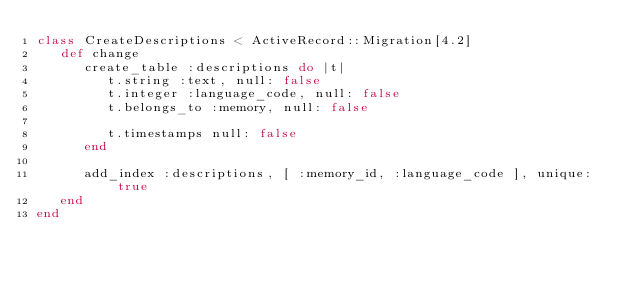<code> <loc_0><loc_0><loc_500><loc_500><_Ruby_>class CreateDescriptions < ActiveRecord::Migration[4.2]
   def change
      create_table :descriptions do |t|
         t.string :text, null: false
         t.integer :language_code, null: false
         t.belongs_to :memory, null: false

         t.timestamps null: false
      end

      add_index :descriptions, [ :memory_id, :language_code ], unique: true
   end
end

</code> 